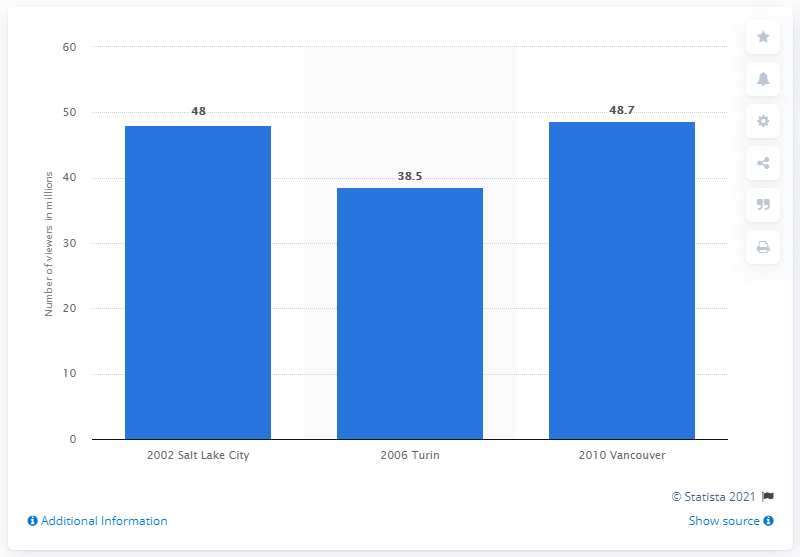Outline some significant characteristics in this image. In 2002, the average minute rating of Olympic Winter Games broadcasts in Salt Lake City was 48. 